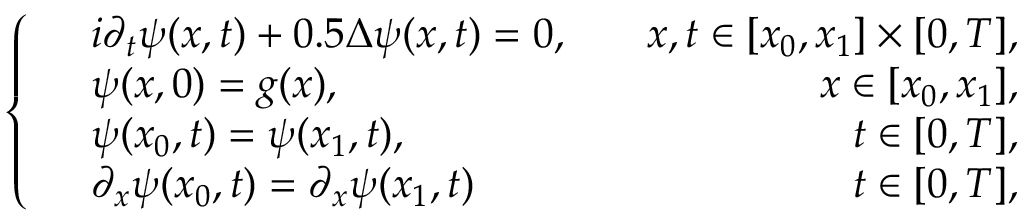<formula> <loc_0><loc_0><loc_500><loc_500>\left \{ \begin{array} { r l r } & { i \partial _ { t } \psi ( x , t ) + 0 . 5 \Delta \psi ( x , t ) = 0 , } & { \quad x , t \in [ x _ { 0 } , x _ { 1 } ] \times [ 0 , T ] , } \\ & { \psi ( x , 0 ) = g ( x ) , } & { \quad x \in [ x _ { 0 } , x _ { 1 } ] , } \\ & { \psi ( x _ { 0 } , t ) = \psi ( x _ { 1 } , t ) , } & { \quad t \in [ 0 , T ] , } \\ & { \partial _ { x } \psi ( x _ { 0 } , t ) = \partial _ { x } \psi ( x _ { 1 } , t ) } & { \quad t \in [ 0 , T ] , } \end{array}</formula> 